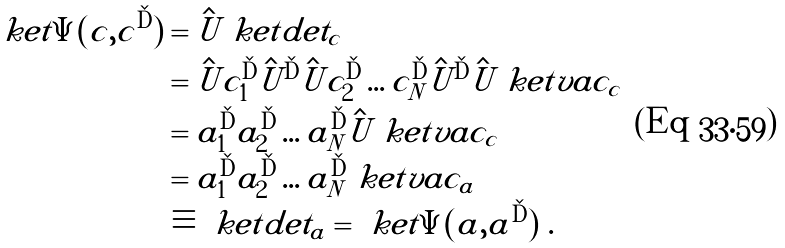Convert formula to latex. <formula><loc_0><loc_0><loc_500><loc_500>\ k e t { \Psi ( c , c ^ { \dag } ) } & = \hat { U } \ k e t { d e t _ { c } } \\ & = \hat { U } c _ { 1 } ^ { \dag } \hat { U } ^ { \dag } \hat { U } c _ { 2 } ^ { \dag } \dots c ^ { \dag } _ { N } \hat { U } ^ { \dag } \hat { U } \ k e t { v a c _ { c } } \\ & = a _ { 1 } ^ { \dag } a _ { 2 } ^ { \dag } \dots a _ { N } ^ { \dag } \hat { U } \ k e t { v a c _ { c } } \\ & = a _ { 1 } ^ { \dag } a _ { 2 } ^ { \dag } \dots a _ { N } ^ { \dag } \ k e t { v a c _ { a } } \\ & \equiv \ k e t { d e t _ { a } } = \ k e t { \Psi ( a , a ^ { \dag } ) } \ .</formula> 